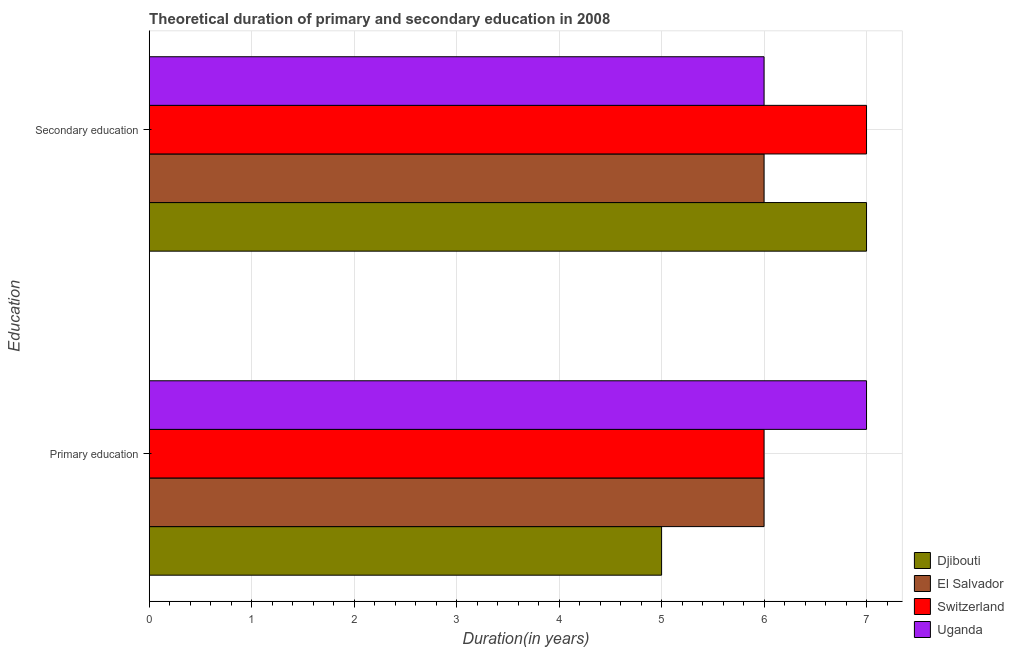How many bars are there on the 1st tick from the top?
Offer a terse response. 4. How many bars are there on the 1st tick from the bottom?
Offer a terse response. 4. What is the label of the 2nd group of bars from the top?
Your answer should be very brief. Primary education. What is the duration of secondary education in Switzerland?
Ensure brevity in your answer.  7. Across all countries, what is the maximum duration of primary education?
Make the answer very short. 7. Across all countries, what is the minimum duration of secondary education?
Give a very brief answer. 6. In which country was the duration of primary education maximum?
Offer a terse response. Uganda. In which country was the duration of primary education minimum?
Make the answer very short. Djibouti. What is the total duration of secondary education in the graph?
Your response must be concise. 26. What is the difference between the duration of secondary education and duration of primary education in Djibouti?
Your answer should be very brief. 2. In how many countries, is the duration of secondary education greater than the average duration of secondary education taken over all countries?
Make the answer very short. 2. What does the 1st bar from the top in Secondary education represents?
Your answer should be compact. Uganda. What does the 4th bar from the bottom in Secondary education represents?
Your answer should be compact. Uganda. How many bars are there?
Give a very brief answer. 8. Are all the bars in the graph horizontal?
Offer a very short reply. Yes. How many countries are there in the graph?
Your answer should be compact. 4. Does the graph contain any zero values?
Provide a succinct answer. No. How many legend labels are there?
Offer a terse response. 4. How are the legend labels stacked?
Your answer should be very brief. Vertical. What is the title of the graph?
Provide a succinct answer. Theoretical duration of primary and secondary education in 2008. What is the label or title of the X-axis?
Your answer should be very brief. Duration(in years). What is the label or title of the Y-axis?
Ensure brevity in your answer.  Education. What is the Duration(in years) of El Salvador in Primary education?
Your answer should be very brief. 6. What is the Duration(in years) of Switzerland in Primary education?
Your answer should be very brief. 6. What is the Duration(in years) of Uganda in Primary education?
Give a very brief answer. 7. What is the Duration(in years) in Switzerland in Secondary education?
Give a very brief answer. 7. What is the Duration(in years) of Uganda in Secondary education?
Provide a short and direct response. 6. Across all Education, what is the maximum Duration(in years) in Djibouti?
Offer a very short reply. 7. Across all Education, what is the maximum Duration(in years) of Switzerland?
Your answer should be very brief. 7. Across all Education, what is the minimum Duration(in years) in El Salvador?
Give a very brief answer. 6. What is the total Duration(in years) in Switzerland in the graph?
Offer a terse response. 13. What is the difference between the Duration(in years) in El Salvador in Primary education and that in Secondary education?
Give a very brief answer. 0. What is the difference between the Duration(in years) in Switzerland in Primary education and that in Secondary education?
Keep it short and to the point. -1. What is the difference between the Duration(in years) of Djibouti in Primary education and the Duration(in years) of El Salvador in Secondary education?
Ensure brevity in your answer.  -1. What is the difference between the Duration(in years) of Switzerland in Primary education and the Duration(in years) of Uganda in Secondary education?
Offer a very short reply. 0. What is the difference between the Duration(in years) of Djibouti and Duration(in years) of Switzerland in Primary education?
Provide a short and direct response. -1. What is the difference between the Duration(in years) in El Salvador and Duration(in years) in Switzerland in Primary education?
Keep it short and to the point. 0. What is the difference between the Duration(in years) of El Salvador and Duration(in years) of Uganda in Primary education?
Your response must be concise. -1. What is the difference between the Duration(in years) in Djibouti and Duration(in years) in El Salvador in Secondary education?
Provide a short and direct response. 1. What is the difference between the Duration(in years) of Djibouti and Duration(in years) of Uganda in Secondary education?
Make the answer very short. 1. What is the difference between the Duration(in years) in El Salvador and Duration(in years) in Switzerland in Secondary education?
Make the answer very short. -1. What is the difference between the Duration(in years) in El Salvador and Duration(in years) in Uganda in Secondary education?
Your answer should be compact. 0. What is the difference between the Duration(in years) in Switzerland and Duration(in years) in Uganda in Secondary education?
Offer a very short reply. 1. What is the ratio of the Duration(in years) in El Salvador in Primary education to that in Secondary education?
Give a very brief answer. 1. What is the ratio of the Duration(in years) of Switzerland in Primary education to that in Secondary education?
Provide a short and direct response. 0.86. What is the ratio of the Duration(in years) in Uganda in Primary education to that in Secondary education?
Offer a very short reply. 1.17. What is the difference between the highest and the second highest Duration(in years) in El Salvador?
Keep it short and to the point. 0. What is the difference between the highest and the second highest Duration(in years) of Switzerland?
Ensure brevity in your answer.  1. 